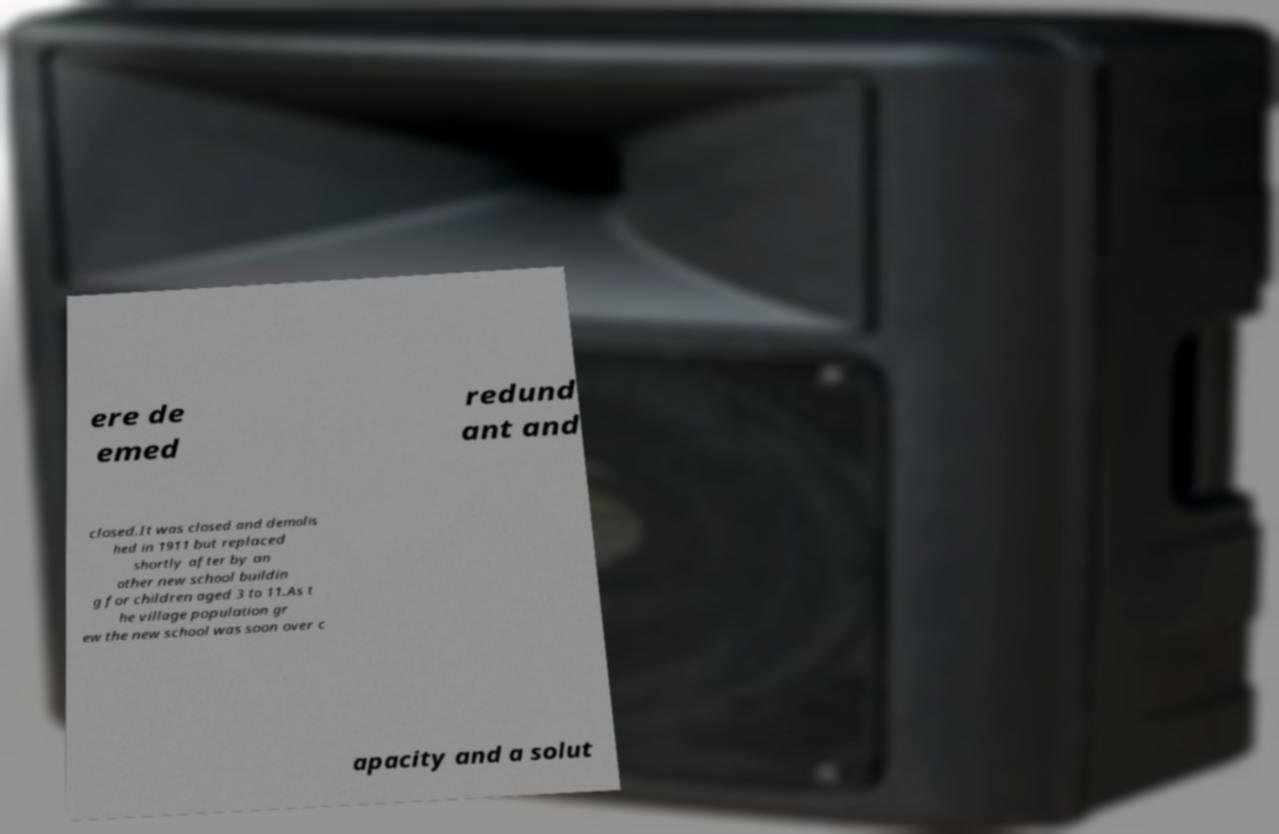Could you extract and type out the text from this image? ere de emed redund ant and closed.It was closed and demolis hed in 1911 but replaced shortly after by an other new school buildin g for children aged 3 to 11.As t he village population gr ew the new school was soon over c apacity and a solut 